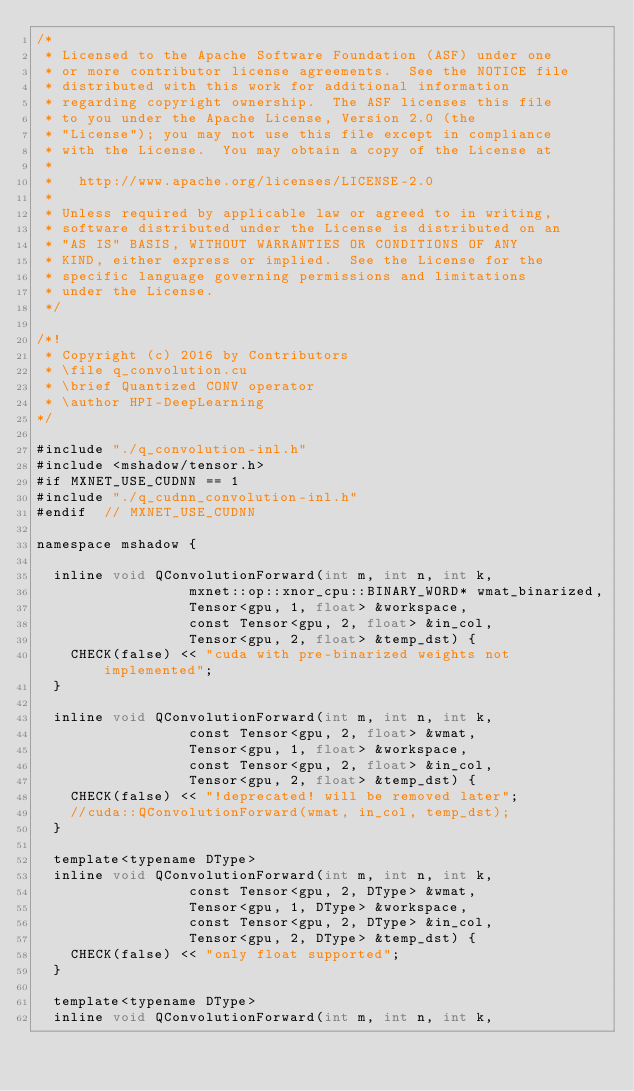<code> <loc_0><loc_0><loc_500><loc_500><_Cuda_>/*
 * Licensed to the Apache Software Foundation (ASF) under one
 * or more contributor license agreements.  See the NOTICE file
 * distributed with this work for additional information
 * regarding copyright ownership.  The ASF licenses this file
 * to you under the Apache License, Version 2.0 (the
 * "License"); you may not use this file except in compliance
 * with the License.  You may obtain a copy of the License at
 *
 *   http://www.apache.org/licenses/LICENSE-2.0
 *
 * Unless required by applicable law or agreed to in writing,
 * software distributed under the License is distributed on an
 * "AS IS" BASIS, WITHOUT WARRANTIES OR CONDITIONS OF ANY
 * KIND, either express or implied.  See the License for the
 * specific language governing permissions and limitations
 * under the License.
 */

/*!
 * Copyright (c) 2016 by Contributors
 * \file q_convolution.cu
 * \brief Quantized CONV operator
 * \author HPI-DeepLearning
*/

#include "./q_convolution-inl.h"
#include <mshadow/tensor.h>
#if MXNET_USE_CUDNN == 1
#include "./q_cudnn_convolution-inl.h"
#endif  // MXNET_USE_CUDNN

namespace mshadow {

	inline void QConvolutionForward(int m, int n, int k,
									mxnet::op::xnor_cpu::BINARY_WORD* wmat_binarized,
									Tensor<gpu, 1, float> &workspace,
									const Tensor<gpu, 2, float> &in_col,
									Tensor<gpu, 2, float> &temp_dst) {
		CHECK(false) << "cuda with pre-binarized weights not implemented";
	}

	inline void QConvolutionForward(int m, int n, int k,
									const Tensor<gpu, 2, float> &wmat,
									Tensor<gpu, 1, float> &workspace,
									const Tensor<gpu, 2, float> &in_col,
									Tensor<gpu, 2, float> &temp_dst) {
    CHECK(false) << "!deprecated! will be removed later";
		//cuda::QConvolutionForward(wmat, in_col, temp_dst);
	}

	template<typename DType>
	inline void QConvolutionForward(int m, int n, int k,
									const Tensor<gpu, 2, DType> &wmat,
									Tensor<gpu, 1, DType> &workspace,
									const Tensor<gpu, 2, DType> &in_col,
									Tensor<gpu, 2, DType> &temp_dst) {
		CHECK(false) << "only float supported";
	}

	template<typename DType>
	inline void QConvolutionForward(int m, int n, int k,</code> 